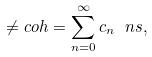<formula> <loc_0><loc_0><loc_500><loc_500>\ne c o h = \sum _ { n = 0 } ^ { \infty } c _ { n } \ n s ,</formula> 